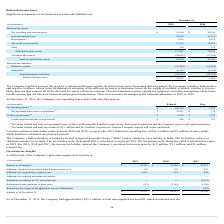According to Pegasystems's financial document, What is excluded from the company's net operating losses calculations?  federal and state net operating losses of $60.2 million and $0.8 million, respectively, from prior acquisitions that the Company expects will expire unutilized. The document states: "(1) Excludes federal and state net operating losses of $60.2 million and $0.8 million, respectively, from prior acquisitions that the Company expects ..." Also, What is excluded from the company's credit carryforward calculations?  federal and state tax credits of $0.1 million and $8.3 million, respectively, that the Company expects will expire unutilized. The document states: "(2) Excludes federal and state tax credits of $0.1 million and $8.3 million, respectively, that the Company expects will expire unutilized...." Also, What is the company's reduction in provision for income taxes arising from its income tax holiday in 2019 and 2018 respectively? The document shows two values: $1.9 million and $1.3 million. From the document: "pany’s provision for income taxes by $1.9 million, $1.3 million, and $1 million, respectively. educed the Company’s provision for income taxes by $1.9..." Also, can you calculate: What is the difference between the company's federal and state net operating losses? Based on the calculation: 120,722 - 3,337 , the result is 117385 (in thousands). This is based on the information: "Net operating losses (1) $ 120,722 $ 3,337 Net operating losses (1) $ 120,722 $ 3,337..." The key data points involved are: 120,722, 3,337. Also, can you calculate: What is the total federal and state credit carryforwards? Based on the calculation: 1,958 + 8,202 , the result is 10160 (in thousands). This is based on the information: "Credit carryforwards (2) $ 8,202 $ 1,958 Credit carryforwards (2) $ 8,202 $ 1,958..." The key data points involved are: 1,958, 8,202. Also, can you calculate: What is the average federal and state credit carryforwards due to acquisitions? To answer this question, I need to perform calculations using the financial data. The calculation is: (640 + 227)/2 , which equals 433.5 (in thousands). This is based on the information: "Credit carryforwards due to acquisitions $ 640 $ 227 Credit carryforwards due to acquisitions $ 640 $ 227..." The key data points involved are: 227, 640. 